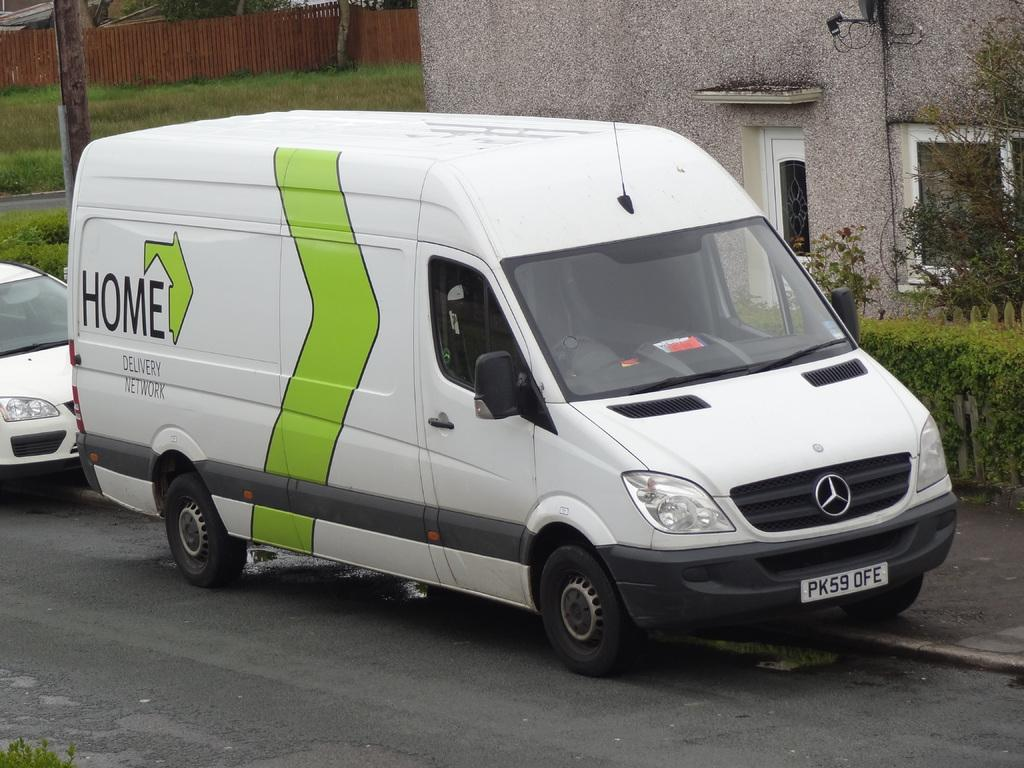<image>
Share a concise interpretation of the image provided. A white Mercedes van says Home Delivery Network on the side. 